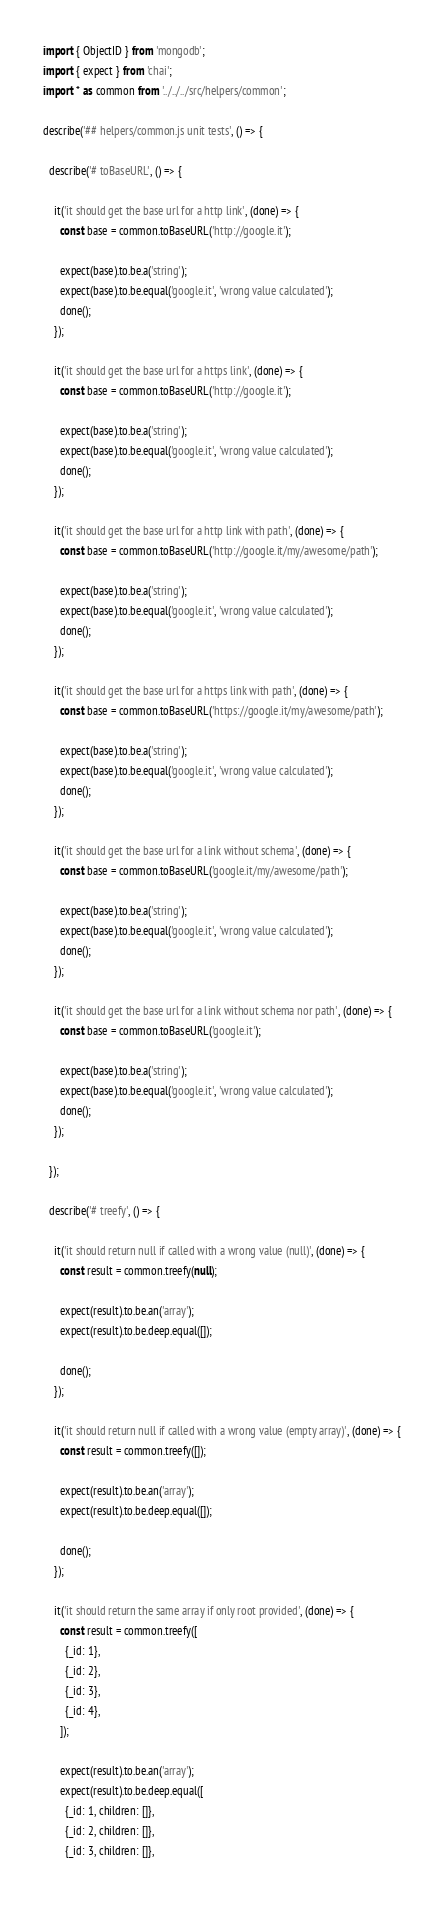Convert code to text. <code><loc_0><loc_0><loc_500><loc_500><_JavaScript_>import { ObjectID } from 'mongodb';
import { expect } from 'chai';
import * as common from '../../../src/helpers/common';

describe('## helpers/common.js unit tests', () => {

  describe('# toBaseURL', () => {

    it('it should get the base url for a http link', (done) => {
      const base = common.toBaseURL('http://google.it');

      expect(base).to.be.a('string');
      expect(base).to.be.equal('google.it', 'wrong value calculated');
      done();
    });

    it('it should get the base url for a https link', (done) => {
      const base = common.toBaseURL('http://google.it');

      expect(base).to.be.a('string');
      expect(base).to.be.equal('google.it', 'wrong value calculated');
      done();
    });

    it('it should get the base url for a http link with path', (done) => {
      const base = common.toBaseURL('http://google.it/my/awesome/path');

      expect(base).to.be.a('string');
      expect(base).to.be.equal('google.it', 'wrong value calculated');
      done();
    });

    it('it should get the base url for a https link with path', (done) => {
      const base = common.toBaseURL('https://google.it/my/awesome/path');

      expect(base).to.be.a('string');
      expect(base).to.be.equal('google.it', 'wrong value calculated');
      done();
    });

    it('it should get the base url for a link without schema', (done) => {
      const base = common.toBaseURL('google.it/my/awesome/path');

      expect(base).to.be.a('string');
      expect(base).to.be.equal('google.it', 'wrong value calculated');
      done();
    });

    it('it should get the base url for a link without schema nor path', (done) => {
      const base = common.toBaseURL('google.it');

      expect(base).to.be.a('string');
      expect(base).to.be.equal('google.it', 'wrong value calculated');
      done();
    });

  });

  describe('# treefy', () => {

    it('it should return null if called with a wrong value (null)', (done) => {
      const result = common.treefy(null);

      expect(result).to.be.an('array');
      expect(result).to.be.deep.equal([]);

      done();
    });

    it('it should return null if called with a wrong value (empty array)', (done) => {
      const result = common.treefy([]);

      expect(result).to.be.an('array');
      expect(result).to.be.deep.equal([]);

      done();
    });

    it('it should return the same array if only root provided', (done) => {
      const result = common.treefy([
        {_id: 1},
        {_id: 2},
        {_id: 3},
        {_id: 4},
      ]);

      expect(result).to.be.an('array');
      expect(result).to.be.deep.equal([
        {_id: 1, children: []},
        {_id: 2, children: []},
        {_id: 3, children: []},</code> 